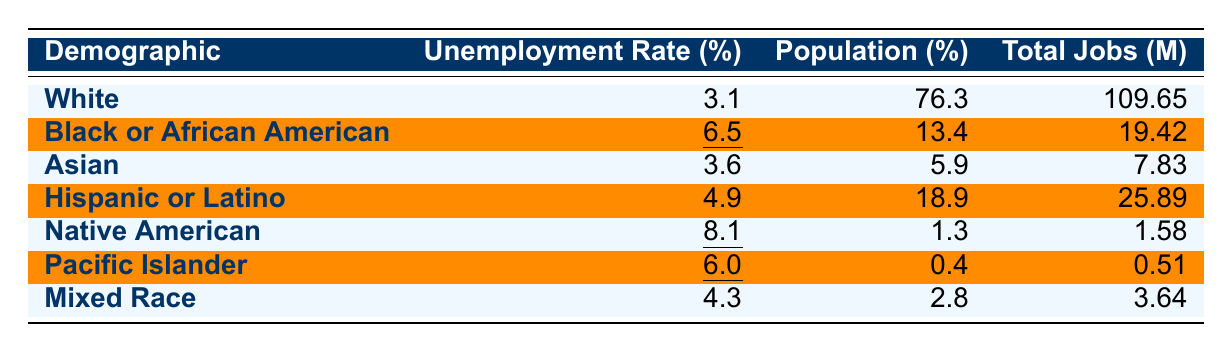What is the unemployment rate for Black or African American individuals? The table shows that the unemployment rate for Black or African American individuals is specifically highlighted with an underline, which indicates its significance. That rate is 6.5%.
Answer: 6.5% Which demographic has the lowest unemployment rate? The unemployment rates for different demographics can be compared directly from the table. The lowest rate is for White individuals at 3.1%.
Answer: 3.1% How many total jobs are there for Hispanic or Latino individuals? The total jobs for Hispanic or Latino individuals is listed directly in the table as 25.89 million.
Answer: 25.89 million Which demographic has the highest population percentage? By examining the population percentages listed in the table, White individuals have the highest percentage at 76.3%.
Answer: 76.3% What is the average unemployment rate for all demographics listed? To find the average unemployment rate, sum the rates (3.1 + 6.5 + 3.6 + 4.9 + 8.1 + 6.0 + 4.3) = 36.5 and divide by the number of demographics (7). The average is 36.5 / 7 ≈ 5.21%.
Answer: 5.21% Is the unemployment rate for Native American individuals higher than that of Asian individuals? The table shows that the unemployment rate for Native American individuals is 8.1% and for Asian individuals is 3.6%. Since 8.1% is greater than 3.6%, the statement is true.
Answer: Yes What is the difference in unemployment rates between Mixed Race and Black or African American individuals? The unemployment rate for Mixed Race individuals is 4.3% and for Black or African American individuals is 6.5%. To find the difference, calculate (6.5 - 4.3) = 2.2%.
Answer: 2.2% If we combine the total jobs of Black or African American and Native American individuals, what would the total be? The total jobs for Black or African American individuals is 19.42 million and for Native American individuals is 1.58 million. Adding these together gives (19.42 + 1.58) = 21 million.
Answer: 21 million What percentage of the total jobs do Pacific Islander individuals represent? The total jobs for Pacific Islander individuals is 0.51 million. To find the percentage of total jobs, first calculate the total jobs of all groups, which is (109.65 + 19.42 + 7.83 + 25.89 + 1.58 + 0.51 + 3.64) = 168.48 million. Then the percentage is (0.51 / 168.48) * 100 ≈ 0.30%.
Answer: 0.30% True or false: All demographic groups have unemployment rates below 9%. By checking each unemployment rate in the table, Black or African American is 6.5%, Native American is 8.1%, and Pacific Islander is 6%. All are below 9%, so the statement is true.
Answer: True 